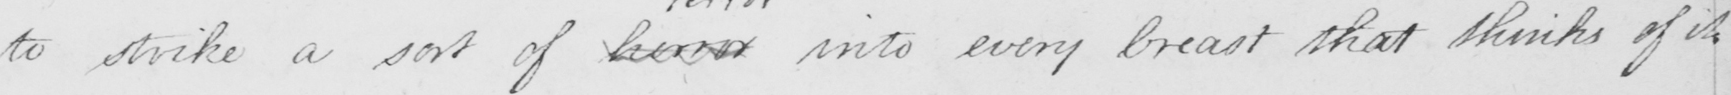Can you read and transcribe this handwriting? to strike a sort of horror into every breast that thinks of it . 